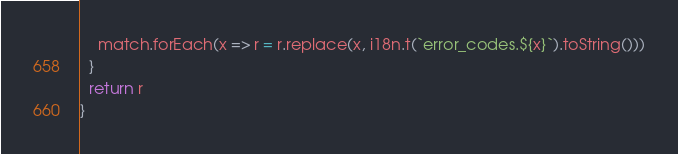<code> <loc_0><loc_0><loc_500><loc_500><_TypeScript_>    match.forEach(x => r = r.replace(x, i18n.t(`error_codes.${x}`).toString()))
  }
  return r
}
</code> 